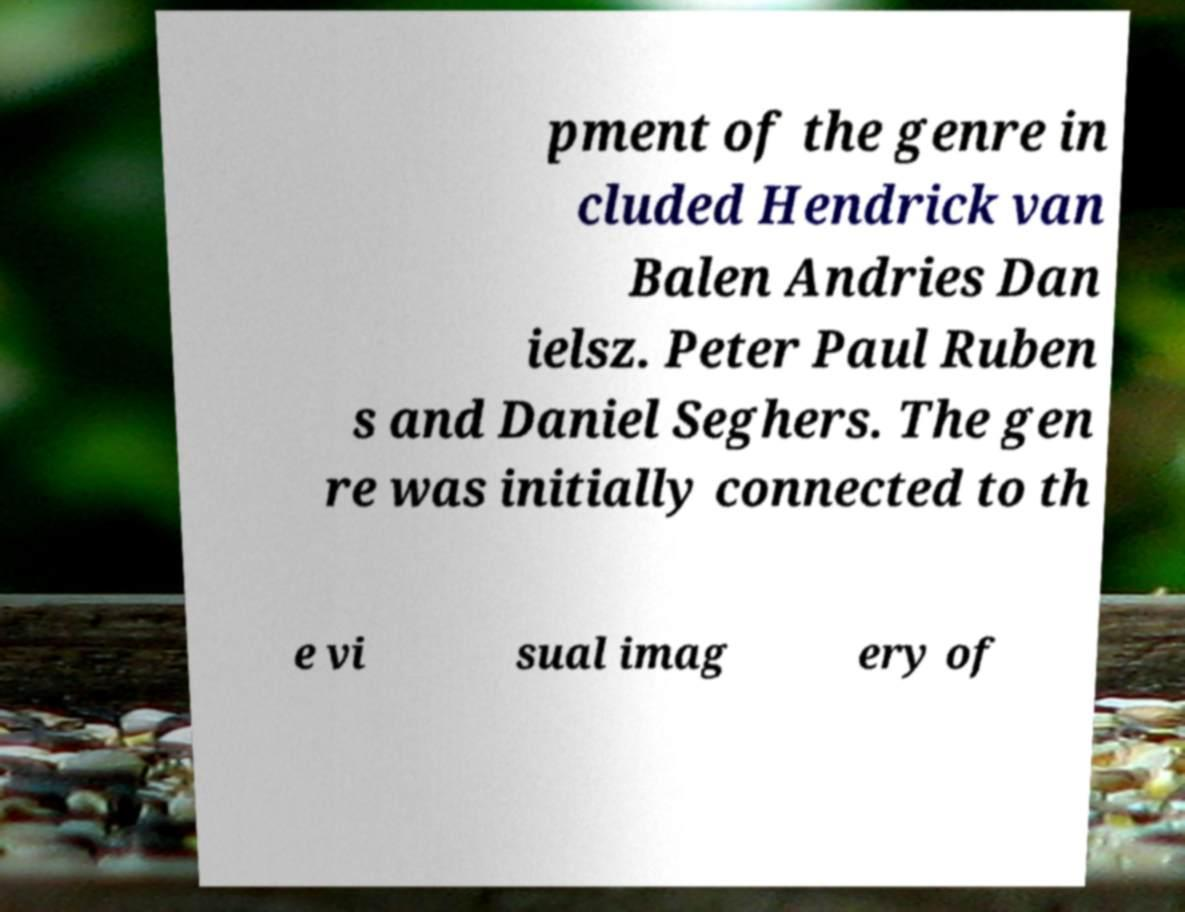For documentation purposes, I need the text within this image transcribed. Could you provide that? pment of the genre in cluded Hendrick van Balen Andries Dan ielsz. Peter Paul Ruben s and Daniel Seghers. The gen re was initially connected to th e vi sual imag ery of 